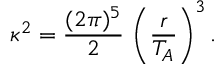<formula> <loc_0><loc_0><loc_500><loc_500>\kappa ^ { 2 } = \frac { ( 2 \pi ) ^ { 5 } } { 2 } \, \left ( \frac { r } { T _ { A } } \right ) ^ { 3 } .</formula> 